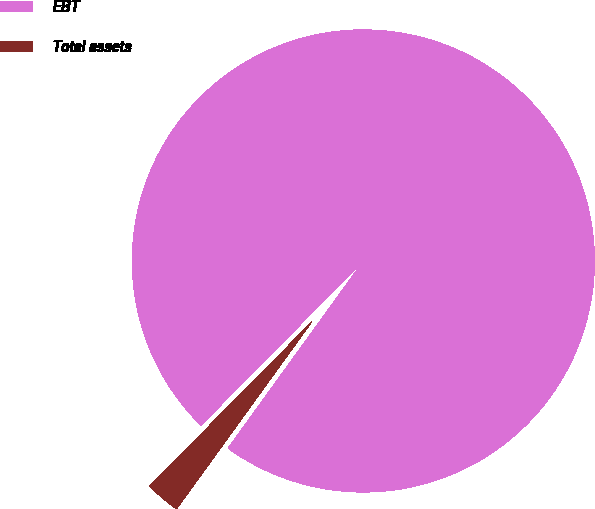Convert chart to OTSL. <chart><loc_0><loc_0><loc_500><loc_500><pie_chart><fcel>EBT<fcel>Total assets<nl><fcel>97.56%<fcel>2.44%<nl></chart> 